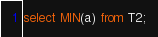<code> <loc_0><loc_0><loc_500><loc_500><_SQL_>select MIN(a) from T2;
</code> 